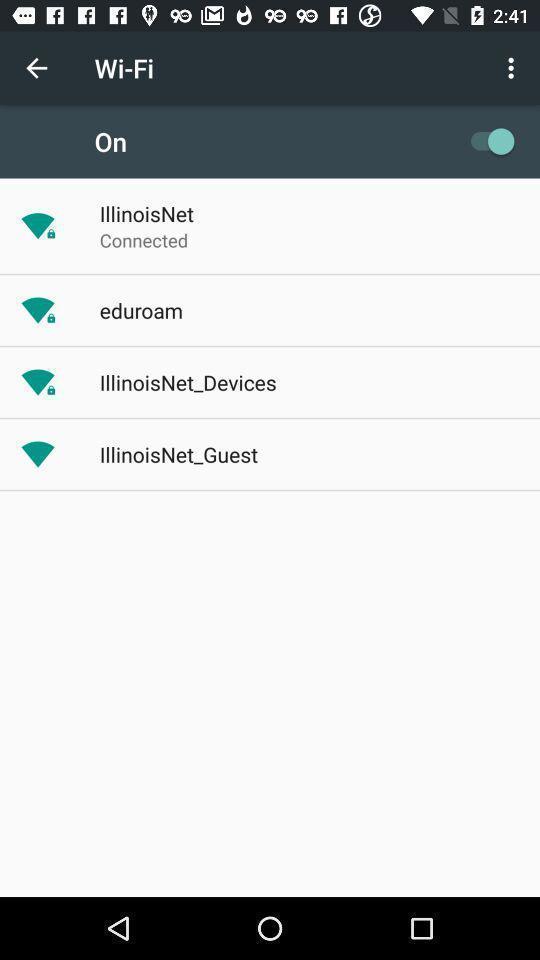Give me a summary of this screen capture. Screen showing wifi signals with on option. 